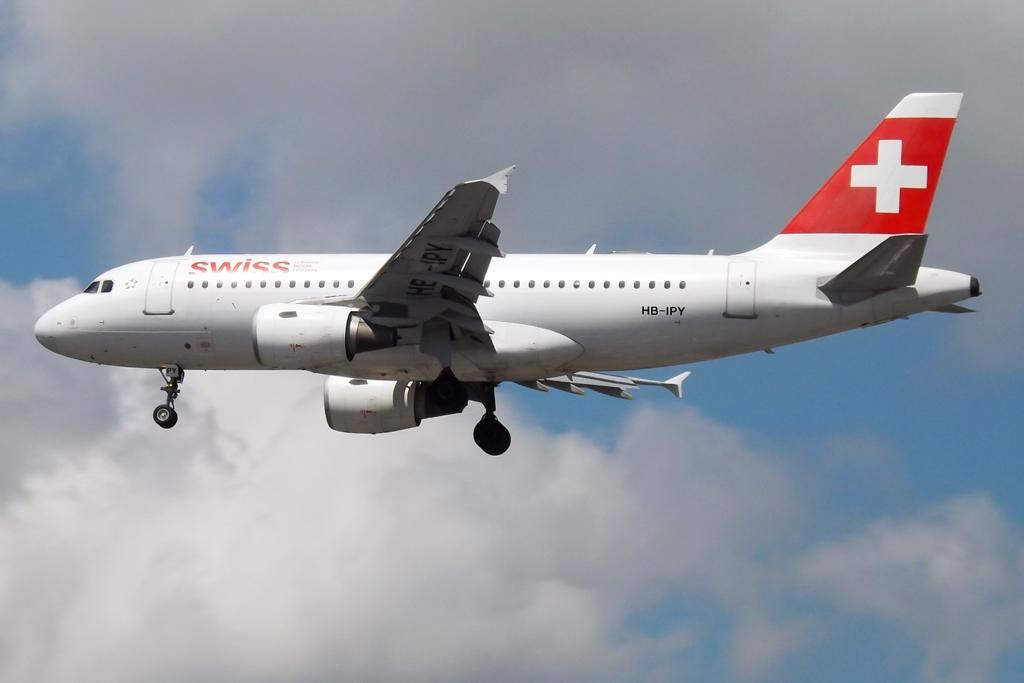Provide a one-sentence caption for the provided image. a white and red swiss airlines airplane in mid flight. 